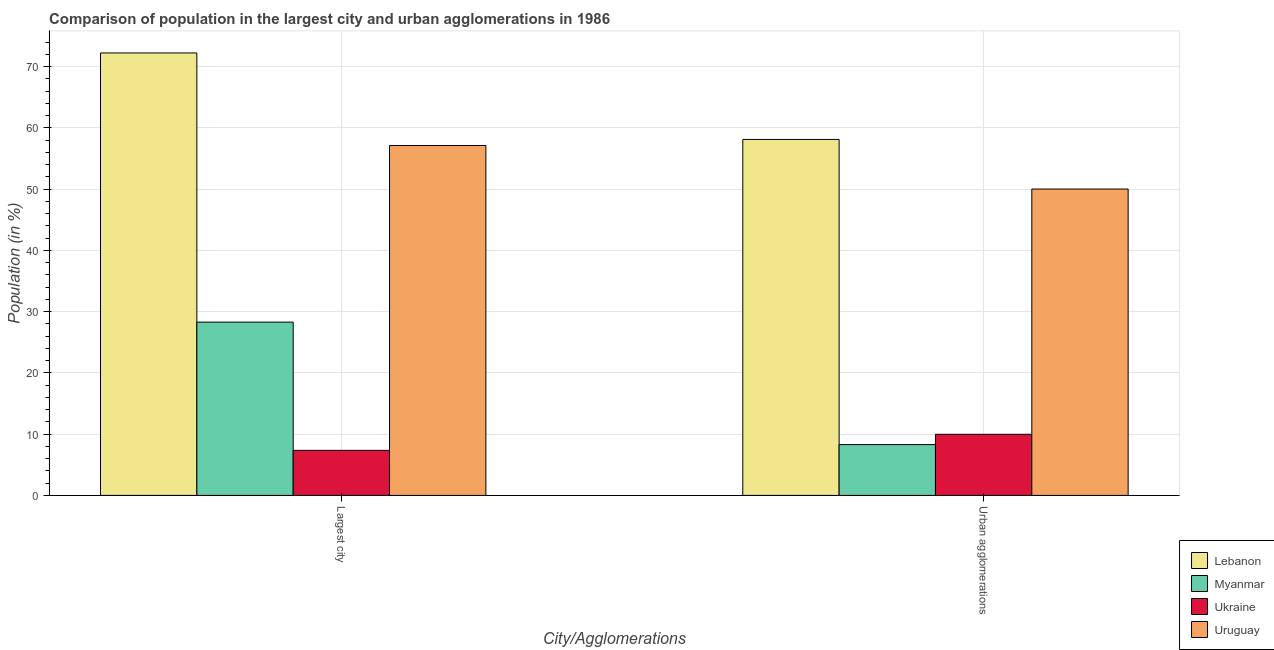How many different coloured bars are there?
Offer a terse response. 4. How many groups of bars are there?
Your response must be concise. 2. What is the label of the 2nd group of bars from the left?
Your answer should be very brief. Urban agglomerations. What is the population in urban agglomerations in Uruguay?
Your answer should be compact. 50.03. Across all countries, what is the maximum population in the largest city?
Provide a succinct answer. 72.25. Across all countries, what is the minimum population in the largest city?
Your response must be concise. 7.36. In which country was the population in urban agglomerations maximum?
Your answer should be compact. Lebanon. In which country was the population in the largest city minimum?
Make the answer very short. Ukraine. What is the total population in urban agglomerations in the graph?
Give a very brief answer. 126.44. What is the difference between the population in urban agglomerations in Myanmar and that in Uruguay?
Offer a very short reply. -41.73. What is the difference between the population in the largest city in Uruguay and the population in urban agglomerations in Lebanon?
Give a very brief answer. -0.99. What is the average population in urban agglomerations per country?
Your response must be concise. 31.61. What is the difference between the population in the largest city and population in urban agglomerations in Ukraine?
Offer a very short reply. -2.62. In how many countries, is the population in urban agglomerations greater than 10 %?
Make the answer very short. 2. What is the ratio of the population in the largest city in Myanmar to that in Lebanon?
Provide a succinct answer. 0.39. In how many countries, is the population in urban agglomerations greater than the average population in urban agglomerations taken over all countries?
Provide a succinct answer. 2. What does the 2nd bar from the left in Urban agglomerations represents?
Your answer should be very brief. Myanmar. What does the 1st bar from the right in Largest city represents?
Ensure brevity in your answer.  Uruguay. How many bars are there?
Your response must be concise. 8. Are all the bars in the graph horizontal?
Ensure brevity in your answer.  No. How many countries are there in the graph?
Keep it short and to the point. 4. What is the difference between two consecutive major ticks on the Y-axis?
Provide a short and direct response. 10. Are the values on the major ticks of Y-axis written in scientific E-notation?
Your response must be concise. No. Does the graph contain any zero values?
Offer a terse response. No. Does the graph contain grids?
Give a very brief answer. Yes. How are the legend labels stacked?
Ensure brevity in your answer.  Vertical. What is the title of the graph?
Give a very brief answer. Comparison of population in the largest city and urban agglomerations in 1986. Does "Small states" appear as one of the legend labels in the graph?
Ensure brevity in your answer.  No. What is the label or title of the X-axis?
Your answer should be compact. City/Agglomerations. What is the Population (in %) in Lebanon in Largest city?
Provide a succinct answer. 72.25. What is the Population (in %) in Myanmar in Largest city?
Your answer should be compact. 28.3. What is the Population (in %) in Ukraine in Largest city?
Your response must be concise. 7.36. What is the Population (in %) in Uruguay in Largest city?
Ensure brevity in your answer.  57.14. What is the Population (in %) of Lebanon in Urban agglomerations?
Make the answer very short. 58.13. What is the Population (in %) in Myanmar in Urban agglomerations?
Give a very brief answer. 8.3. What is the Population (in %) of Ukraine in Urban agglomerations?
Your response must be concise. 9.98. What is the Population (in %) of Uruguay in Urban agglomerations?
Provide a succinct answer. 50.03. Across all City/Agglomerations, what is the maximum Population (in %) in Lebanon?
Keep it short and to the point. 72.25. Across all City/Agglomerations, what is the maximum Population (in %) in Myanmar?
Provide a short and direct response. 28.3. Across all City/Agglomerations, what is the maximum Population (in %) of Ukraine?
Provide a short and direct response. 9.98. Across all City/Agglomerations, what is the maximum Population (in %) of Uruguay?
Your response must be concise. 57.14. Across all City/Agglomerations, what is the minimum Population (in %) in Lebanon?
Your response must be concise. 58.13. Across all City/Agglomerations, what is the minimum Population (in %) of Myanmar?
Your answer should be compact. 8.3. Across all City/Agglomerations, what is the minimum Population (in %) of Ukraine?
Your response must be concise. 7.36. Across all City/Agglomerations, what is the minimum Population (in %) in Uruguay?
Ensure brevity in your answer.  50.03. What is the total Population (in %) of Lebanon in the graph?
Offer a very short reply. 130.38. What is the total Population (in %) of Myanmar in the graph?
Your response must be concise. 36.6. What is the total Population (in %) in Ukraine in the graph?
Offer a terse response. 17.34. What is the total Population (in %) in Uruguay in the graph?
Give a very brief answer. 107.17. What is the difference between the Population (in %) of Lebanon in Largest city and that in Urban agglomerations?
Give a very brief answer. 14.12. What is the difference between the Population (in %) in Myanmar in Largest city and that in Urban agglomerations?
Your answer should be compact. 20. What is the difference between the Population (in %) in Ukraine in Largest city and that in Urban agglomerations?
Your answer should be compact. -2.62. What is the difference between the Population (in %) in Uruguay in Largest city and that in Urban agglomerations?
Your answer should be very brief. 7.11. What is the difference between the Population (in %) of Lebanon in Largest city and the Population (in %) of Myanmar in Urban agglomerations?
Offer a terse response. 63.95. What is the difference between the Population (in %) of Lebanon in Largest city and the Population (in %) of Ukraine in Urban agglomerations?
Make the answer very short. 62.27. What is the difference between the Population (in %) of Lebanon in Largest city and the Population (in %) of Uruguay in Urban agglomerations?
Give a very brief answer. 22.22. What is the difference between the Population (in %) in Myanmar in Largest city and the Population (in %) in Ukraine in Urban agglomerations?
Make the answer very short. 18.32. What is the difference between the Population (in %) of Myanmar in Largest city and the Population (in %) of Uruguay in Urban agglomerations?
Offer a terse response. -21.73. What is the difference between the Population (in %) in Ukraine in Largest city and the Population (in %) in Uruguay in Urban agglomerations?
Provide a succinct answer. -42.67. What is the average Population (in %) in Lebanon per City/Agglomerations?
Make the answer very short. 65.19. What is the average Population (in %) of Myanmar per City/Agglomerations?
Make the answer very short. 18.3. What is the average Population (in %) of Ukraine per City/Agglomerations?
Keep it short and to the point. 8.67. What is the average Population (in %) in Uruguay per City/Agglomerations?
Provide a succinct answer. 53.58. What is the difference between the Population (in %) in Lebanon and Population (in %) in Myanmar in Largest city?
Ensure brevity in your answer.  43.95. What is the difference between the Population (in %) of Lebanon and Population (in %) of Ukraine in Largest city?
Provide a short and direct response. 64.89. What is the difference between the Population (in %) in Lebanon and Population (in %) in Uruguay in Largest city?
Offer a terse response. 15.11. What is the difference between the Population (in %) of Myanmar and Population (in %) of Ukraine in Largest city?
Make the answer very short. 20.94. What is the difference between the Population (in %) of Myanmar and Population (in %) of Uruguay in Largest city?
Offer a terse response. -28.84. What is the difference between the Population (in %) of Ukraine and Population (in %) of Uruguay in Largest city?
Your answer should be compact. -49.78. What is the difference between the Population (in %) of Lebanon and Population (in %) of Myanmar in Urban agglomerations?
Provide a succinct answer. 49.83. What is the difference between the Population (in %) in Lebanon and Population (in %) in Ukraine in Urban agglomerations?
Offer a terse response. 48.15. What is the difference between the Population (in %) in Lebanon and Population (in %) in Uruguay in Urban agglomerations?
Make the answer very short. 8.1. What is the difference between the Population (in %) in Myanmar and Population (in %) in Ukraine in Urban agglomerations?
Provide a short and direct response. -1.68. What is the difference between the Population (in %) of Myanmar and Population (in %) of Uruguay in Urban agglomerations?
Provide a succinct answer. -41.73. What is the difference between the Population (in %) in Ukraine and Population (in %) in Uruguay in Urban agglomerations?
Give a very brief answer. -40.05. What is the ratio of the Population (in %) in Lebanon in Largest city to that in Urban agglomerations?
Make the answer very short. 1.24. What is the ratio of the Population (in %) in Myanmar in Largest city to that in Urban agglomerations?
Your response must be concise. 3.41. What is the ratio of the Population (in %) in Ukraine in Largest city to that in Urban agglomerations?
Your answer should be compact. 0.74. What is the ratio of the Population (in %) in Uruguay in Largest city to that in Urban agglomerations?
Provide a succinct answer. 1.14. What is the difference between the highest and the second highest Population (in %) in Lebanon?
Ensure brevity in your answer.  14.12. What is the difference between the highest and the second highest Population (in %) in Myanmar?
Offer a very short reply. 20. What is the difference between the highest and the second highest Population (in %) in Ukraine?
Your answer should be compact. 2.62. What is the difference between the highest and the second highest Population (in %) in Uruguay?
Offer a terse response. 7.11. What is the difference between the highest and the lowest Population (in %) of Lebanon?
Ensure brevity in your answer.  14.12. What is the difference between the highest and the lowest Population (in %) in Myanmar?
Offer a very short reply. 20. What is the difference between the highest and the lowest Population (in %) of Ukraine?
Keep it short and to the point. 2.62. What is the difference between the highest and the lowest Population (in %) in Uruguay?
Give a very brief answer. 7.11. 